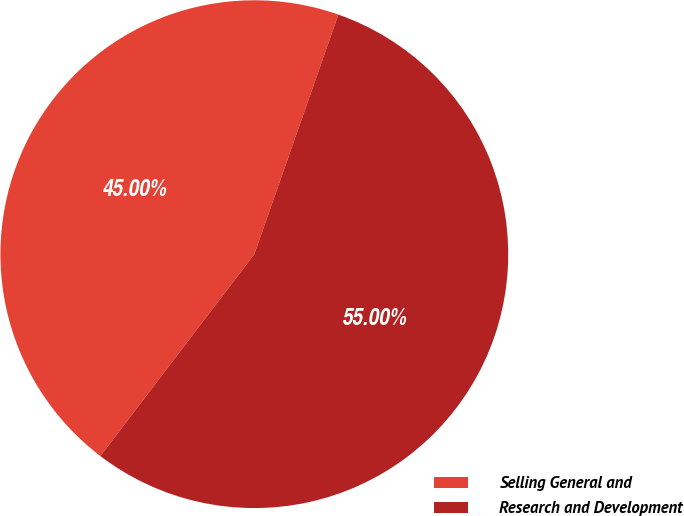Convert chart. <chart><loc_0><loc_0><loc_500><loc_500><pie_chart><fcel>Selling General and<fcel>Research and Development<nl><fcel>45.0%<fcel>55.0%<nl></chart> 